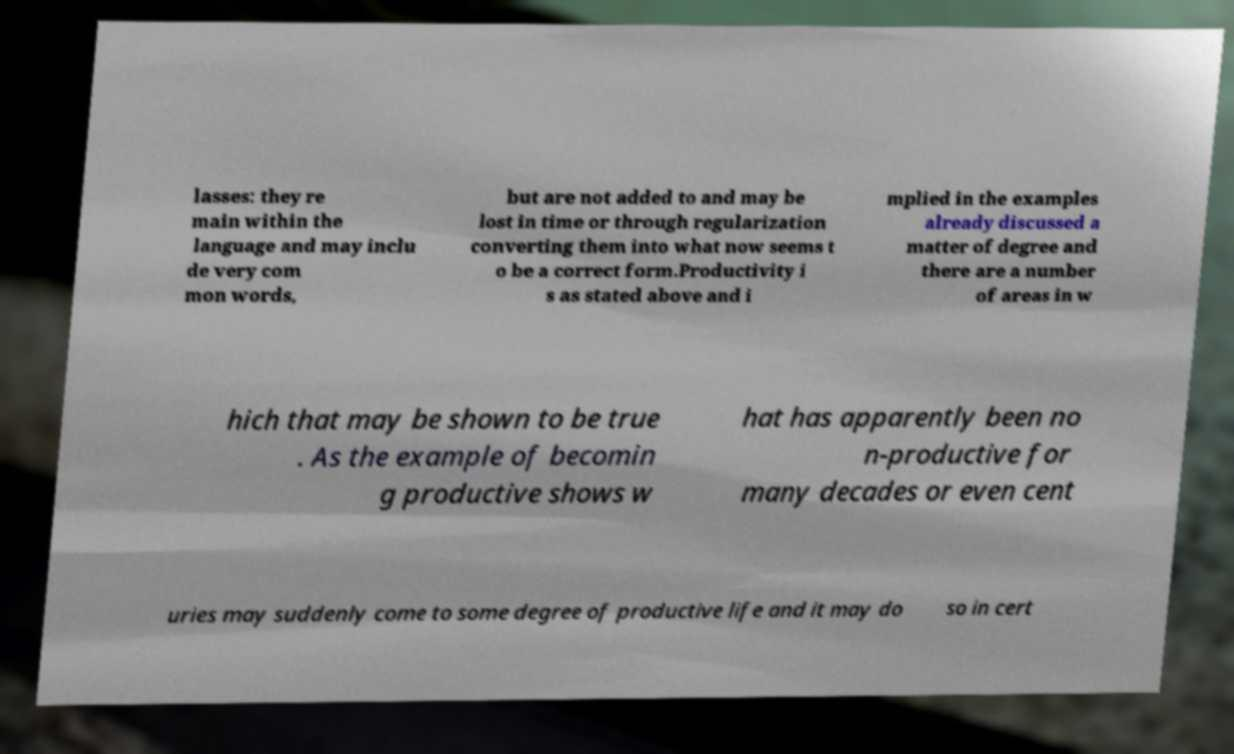For documentation purposes, I need the text within this image transcribed. Could you provide that? lasses: they re main within the language and may inclu de very com mon words, but are not added to and may be lost in time or through regularization converting them into what now seems t o be a correct form.Productivity i s as stated above and i mplied in the examples already discussed a matter of degree and there are a number of areas in w hich that may be shown to be true . As the example of becomin g productive shows w hat has apparently been no n-productive for many decades or even cent uries may suddenly come to some degree of productive life and it may do so in cert 